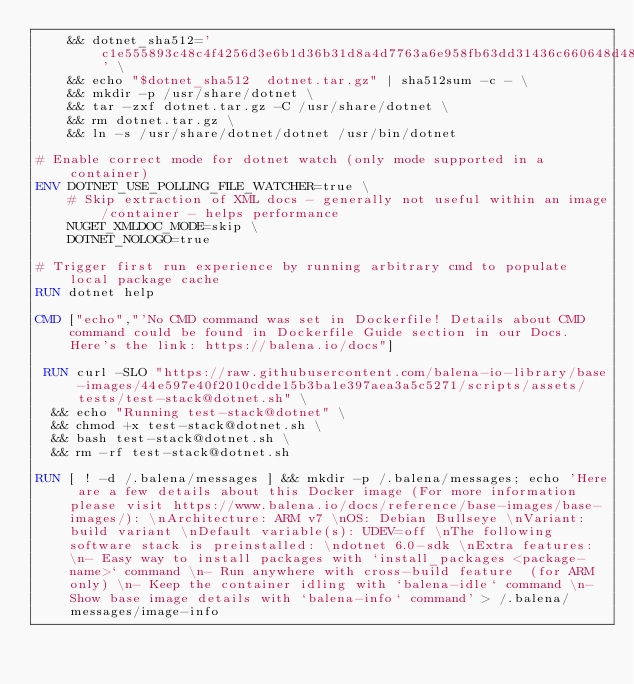<code> <loc_0><loc_0><loc_500><loc_500><_Dockerfile_>    && dotnet_sha512='c1e555893c48c4f4256d3e6b1d36b31d8a4d7763a6e958fb63dd31436c660648d481612b5e25d79a613e84a1954f5eac2c9c2b740bf410958172780f7bbeaeb3' \
    && echo "$dotnet_sha512  dotnet.tar.gz" | sha512sum -c - \
    && mkdir -p /usr/share/dotnet \
    && tar -zxf dotnet.tar.gz -C /usr/share/dotnet \
    && rm dotnet.tar.gz \
    && ln -s /usr/share/dotnet/dotnet /usr/bin/dotnet

# Enable correct mode for dotnet watch (only mode supported in a container)
ENV DOTNET_USE_POLLING_FILE_WATCHER=true \
    # Skip extraction of XML docs - generally not useful within an image/container - helps performance
    NUGET_XMLDOC_MODE=skip \
    DOTNET_NOLOGO=true

# Trigger first run experience by running arbitrary cmd to populate local package cache
RUN dotnet help

CMD ["echo","'No CMD command was set in Dockerfile! Details about CMD command could be found in Dockerfile Guide section in our Docs. Here's the link: https://balena.io/docs"]

 RUN curl -SLO "https://raw.githubusercontent.com/balena-io-library/base-images/44e597e40f2010cdde15b3ba1e397aea3a5c5271/scripts/assets/tests/test-stack@dotnet.sh" \
  && echo "Running test-stack@dotnet" \
  && chmod +x test-stack@dotnet.sh \
  && bash test-stack@dotnet.sh \
  && rm -rf test-stack@dotnet.sh 

RUN [ ! -d /.balena/messages ] && mkdir -p /.balena/messages; echo 'Here are a few details about this Docker image (For more information please visit https://www.balena.io/docs/reference/base-images/base-images/): \nArchitecture: ARM v7 \nOS: Debian Bullseye \nVariant: build variant \nDefault variable(s): UDEV=off \nThe following software stack is preinstalled: \ndotnet 6.0-sdk \nExtra features: \n- Easy way to install packages with `install_packages <package-name>` command \n- Run anywhere with cross-build feature  (for ARM only) \n- Keep the container idling with `balena-idle` command \n- Show base image details with `balena-info` command' > /.balena/messages/image-info
</code> 